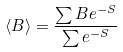<formula> <loc_0><loc_0><loc_500><loc_500>\left \langle B \right \rangle = \frac { \sum B e ^ { - S } } { \sum e ^ { - S } }</formula> 